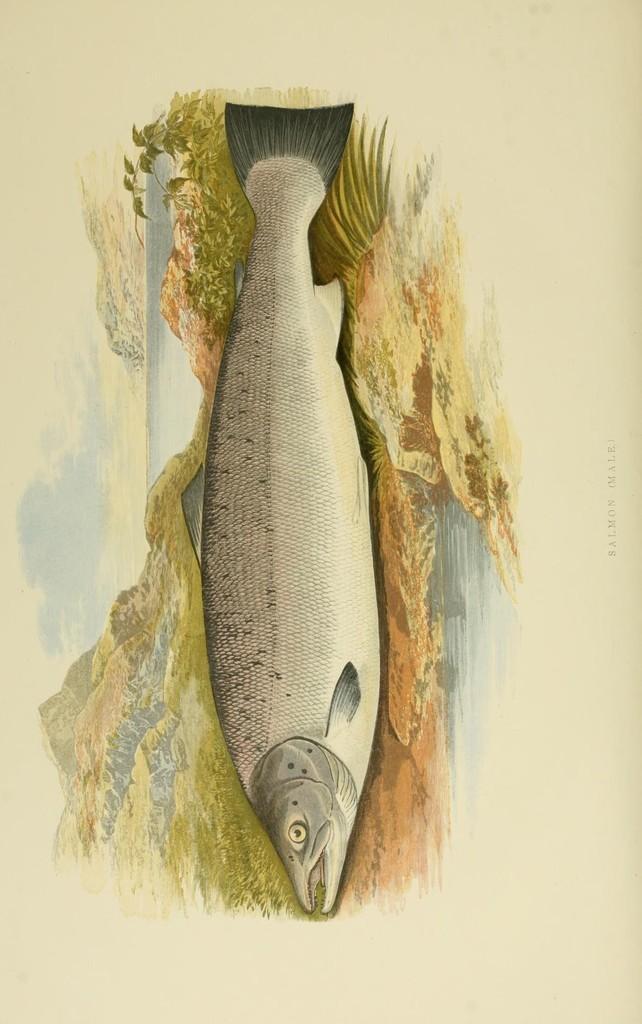Can you describe this image briefly? In this image we can see a picture of a fish. 